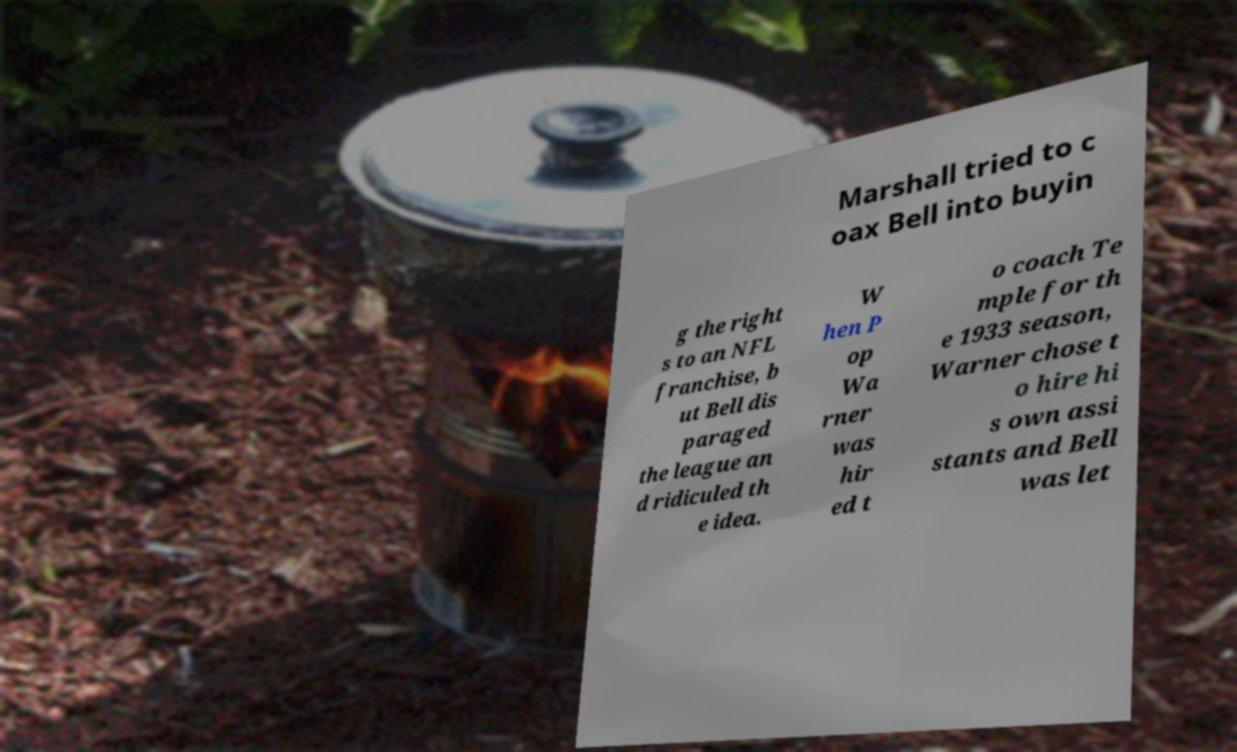Please read and relay the text visible in this image. What does it say? Marshall tried to c oax Bell into buyin g the right s to an NFL franchise, b ut Bell dis paraged the league an d ridiculed th e idea. W hen P op Wa rner was hir ed t o coach Te mple for th e 1933 season, Warner chose t o hire hi s own assi stants and Bell was let 